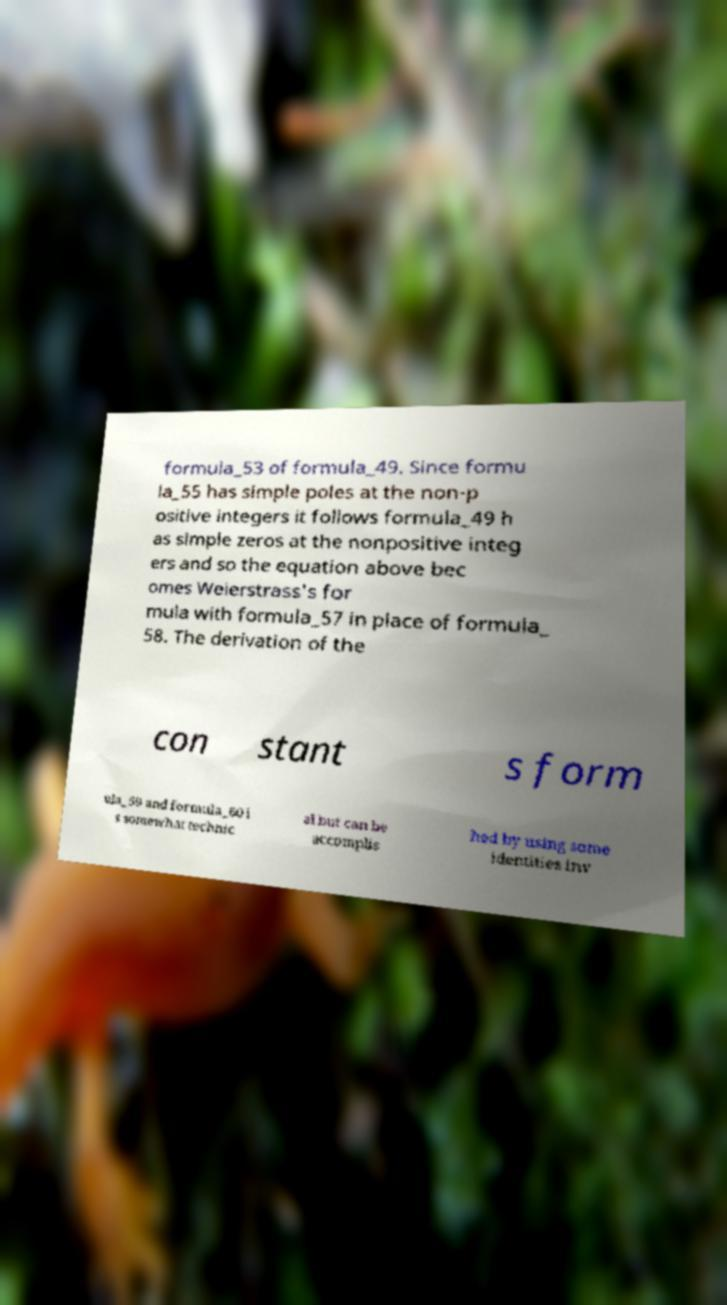Could you extract and type out the text from this image? formula_53 of formula_49. Since formu la_55 has simple poles at the non-p ositive integers it follows formula_49 h as simple zeros at the nonpositive integ ers and so the equation above bec omes Weierstrass's for mula with formula_57 in place of formula_ 58. The derivation of the con stant s form ula_59 and formula_60 i s somewhat technic al but can be accomplis hed by using some identities inv 